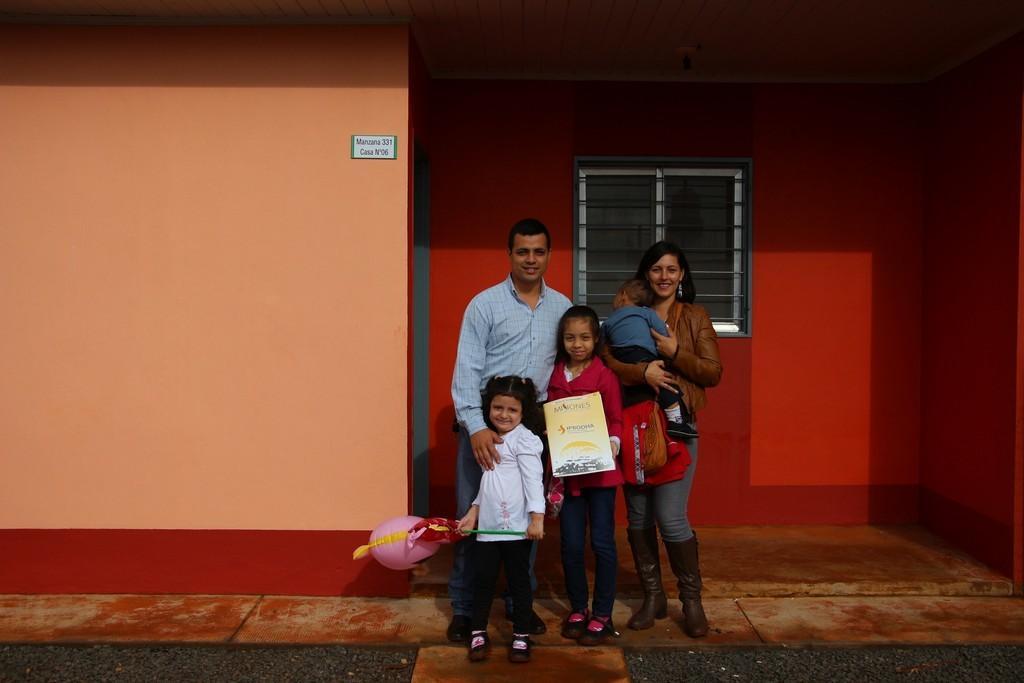Describe this image in one or two sentences. In this picture there is a image of the family with a man and two children. On the left side we can see a woman holding a small kid in the hand. In the background there is a red color wall with the white window. On the left side there is a orange color wall. 